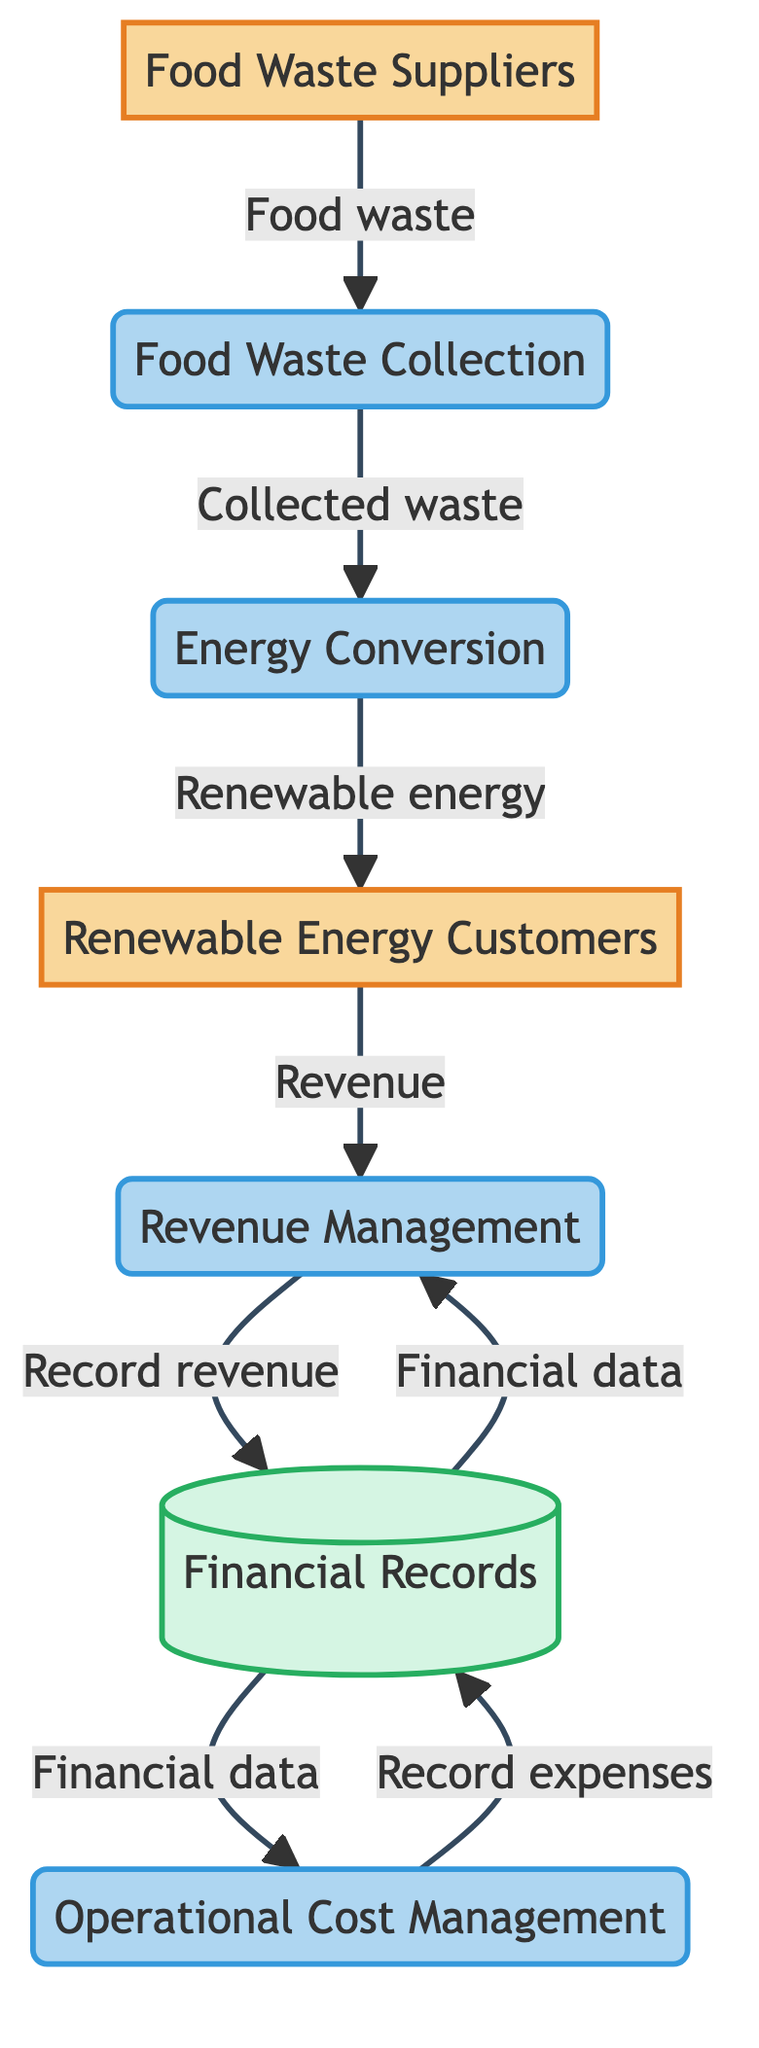What is the number of processes in the diagram? There are five processes in the diagram: Food Waste Collection, Energy Conversion, Revenue Management, Operational Cost Management, and the transition to Financial Records.
Answer: 5 What does Food Waste Suppliers provide to the process? Food Waste Suppliers provide food waste, which is the initial input for the Food Waste Collection process.
Answer: Food waste Where does the renewable energy flow after it is created? Renewable energy flows from the Energy Conversion process to the Renewable Energy Customers, indicating the direction of energy distribution.
Answer: Renewable Energy Customers How is revenue recorded in the system? Revenue generated from Renewable Energy Customers flows into Revenue Management, which subsequently records that revenue into Financial Records for future reference.
Answer: Financial Records What is the relationship between Operational Cost Management and Financial Records? Operational Cost Management records expenses directly into Financial Records, establishing a link between the costs incurred and financial tracking.
Answer: Record expenses How many external entities are present in the diagram? The diagram contains two external entities: Food Waste Suppliers and Renewable Energy Customers, which interact with the internal processes.
Answer: 2 What data flow follows the conversion of energy? After conversion, the renewable energy data flow proceeds from Energy Conversion to Renewable Energy Customers, illustrating the delivery of the generated product.
Answer: Renewable energy What purpose does the Financial Records data store serve? The Financial Records data store serves as the repository for all recorded revenues from Revenue Management and expenses from Operational Cost Management, ensuring a comprehensive financial overview.
Answer: Comprehensive financial overview What initiates the food waste conversion process? The conversion process is initiated by food waste collected from Food Waste Suppliers, marking the starting point of the overall operation chain.
Answer: Food Waste Collection 